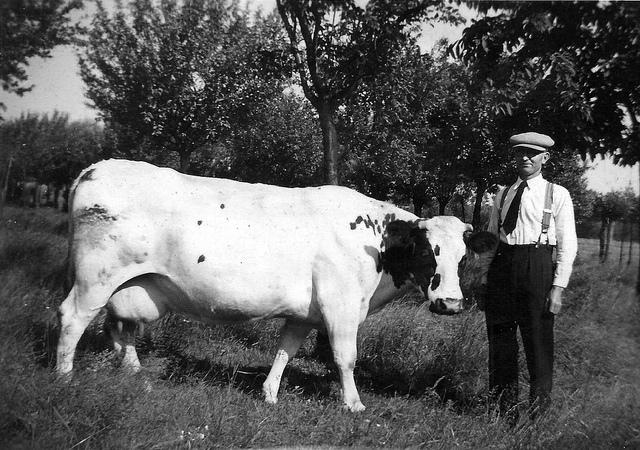Which decade was the photo taking in?
Give a very brief answer. 1950's. What is next to the man?
Concise answer only. Cow. What is the man standing with?
Keep it brief. Cow. What color is the cow?
Give a very brief answer. White and black. What is holding the man's pants up?
Quick response, please. Suspenders. 